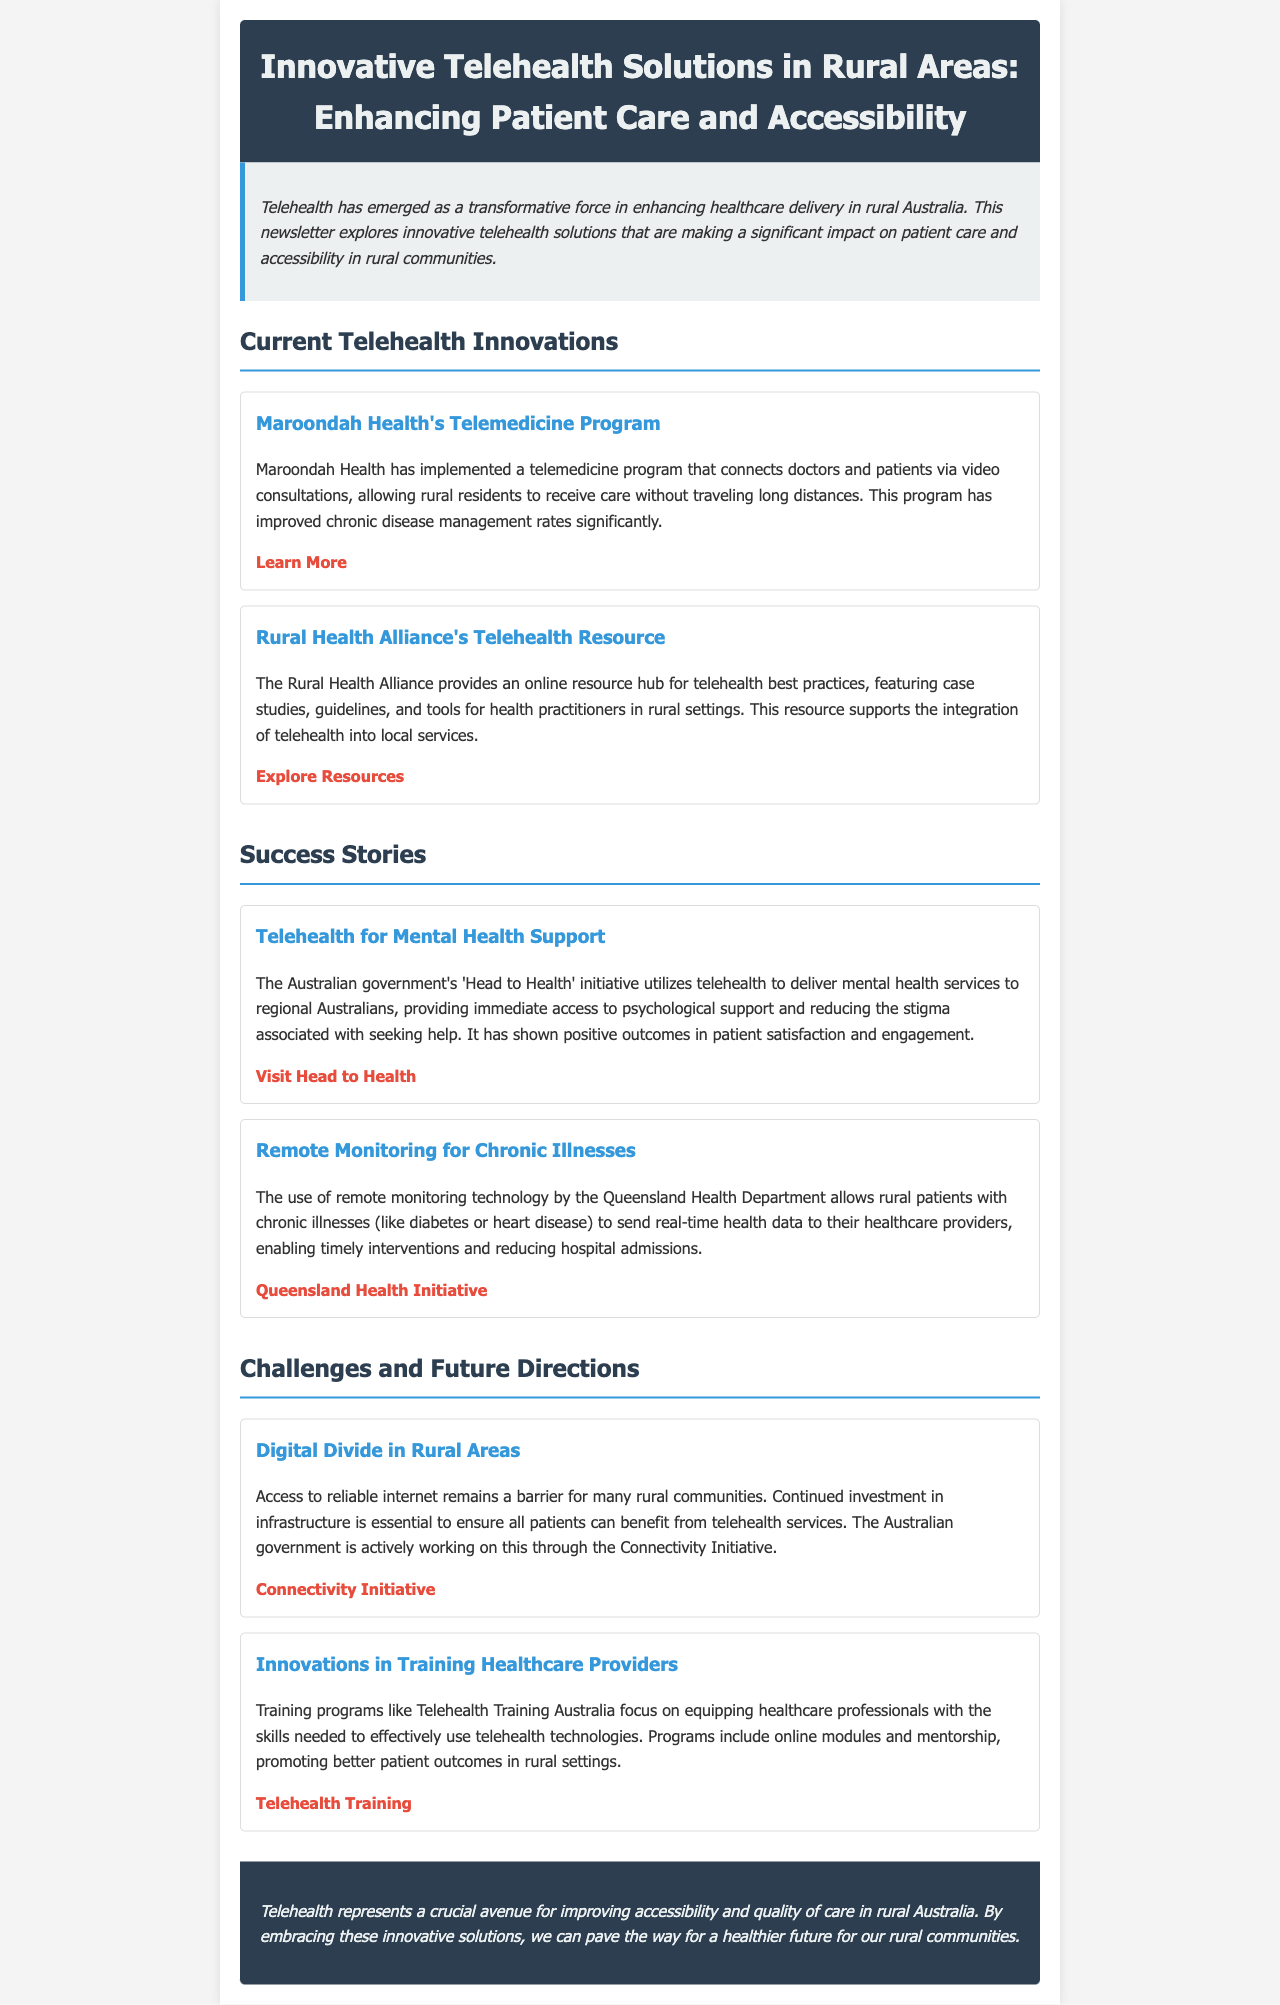what is the title of the newsletter? The title is found in the header section, which introduces the main topic the newsletter covers.
Answer: Innovative Telehealth Solutions in Rural Areas: Enhancing Patient Care and Accessibility what is one of the services offered by Maroondah Health? This information is contained in the section discussing current telehealth innovations, specifically the program details.
Answer: Video consultations what initiative does the Australian government use to support mental health? This information can be located in the success stories section where various initiatives are highlighted.
Answer: Head to Health what challenge is mentioned regarding telehealth accessibility? The challenges section outlines a significant barrier that affects the implementation of telehealth services.
Answer: Digital Divide which resource provides best practices for telehealth integration? This relates to the current telehealth innovations section where various resources are mentioned for healthcare practitioners.
Answer: Rural Health Alliance's Telehealth Resource what is a benefit of remote monitoring technology mentioned? This is found in the success stories section and illustrates the technology's impact on patient care.
Answer: Timely interventions what is the purpose of Telehealth Training Australia? This inquiry refers to the section on training innovations, focusing on the program's goals for healthcare providers.
Answer: Skills equipping how does the newsletter describe the impact of telehealth on rural communities? This is derived from the closing remarks of the document that reflect on the overall significance of telehealth.
Answer: Improving accessibility and quality of care 